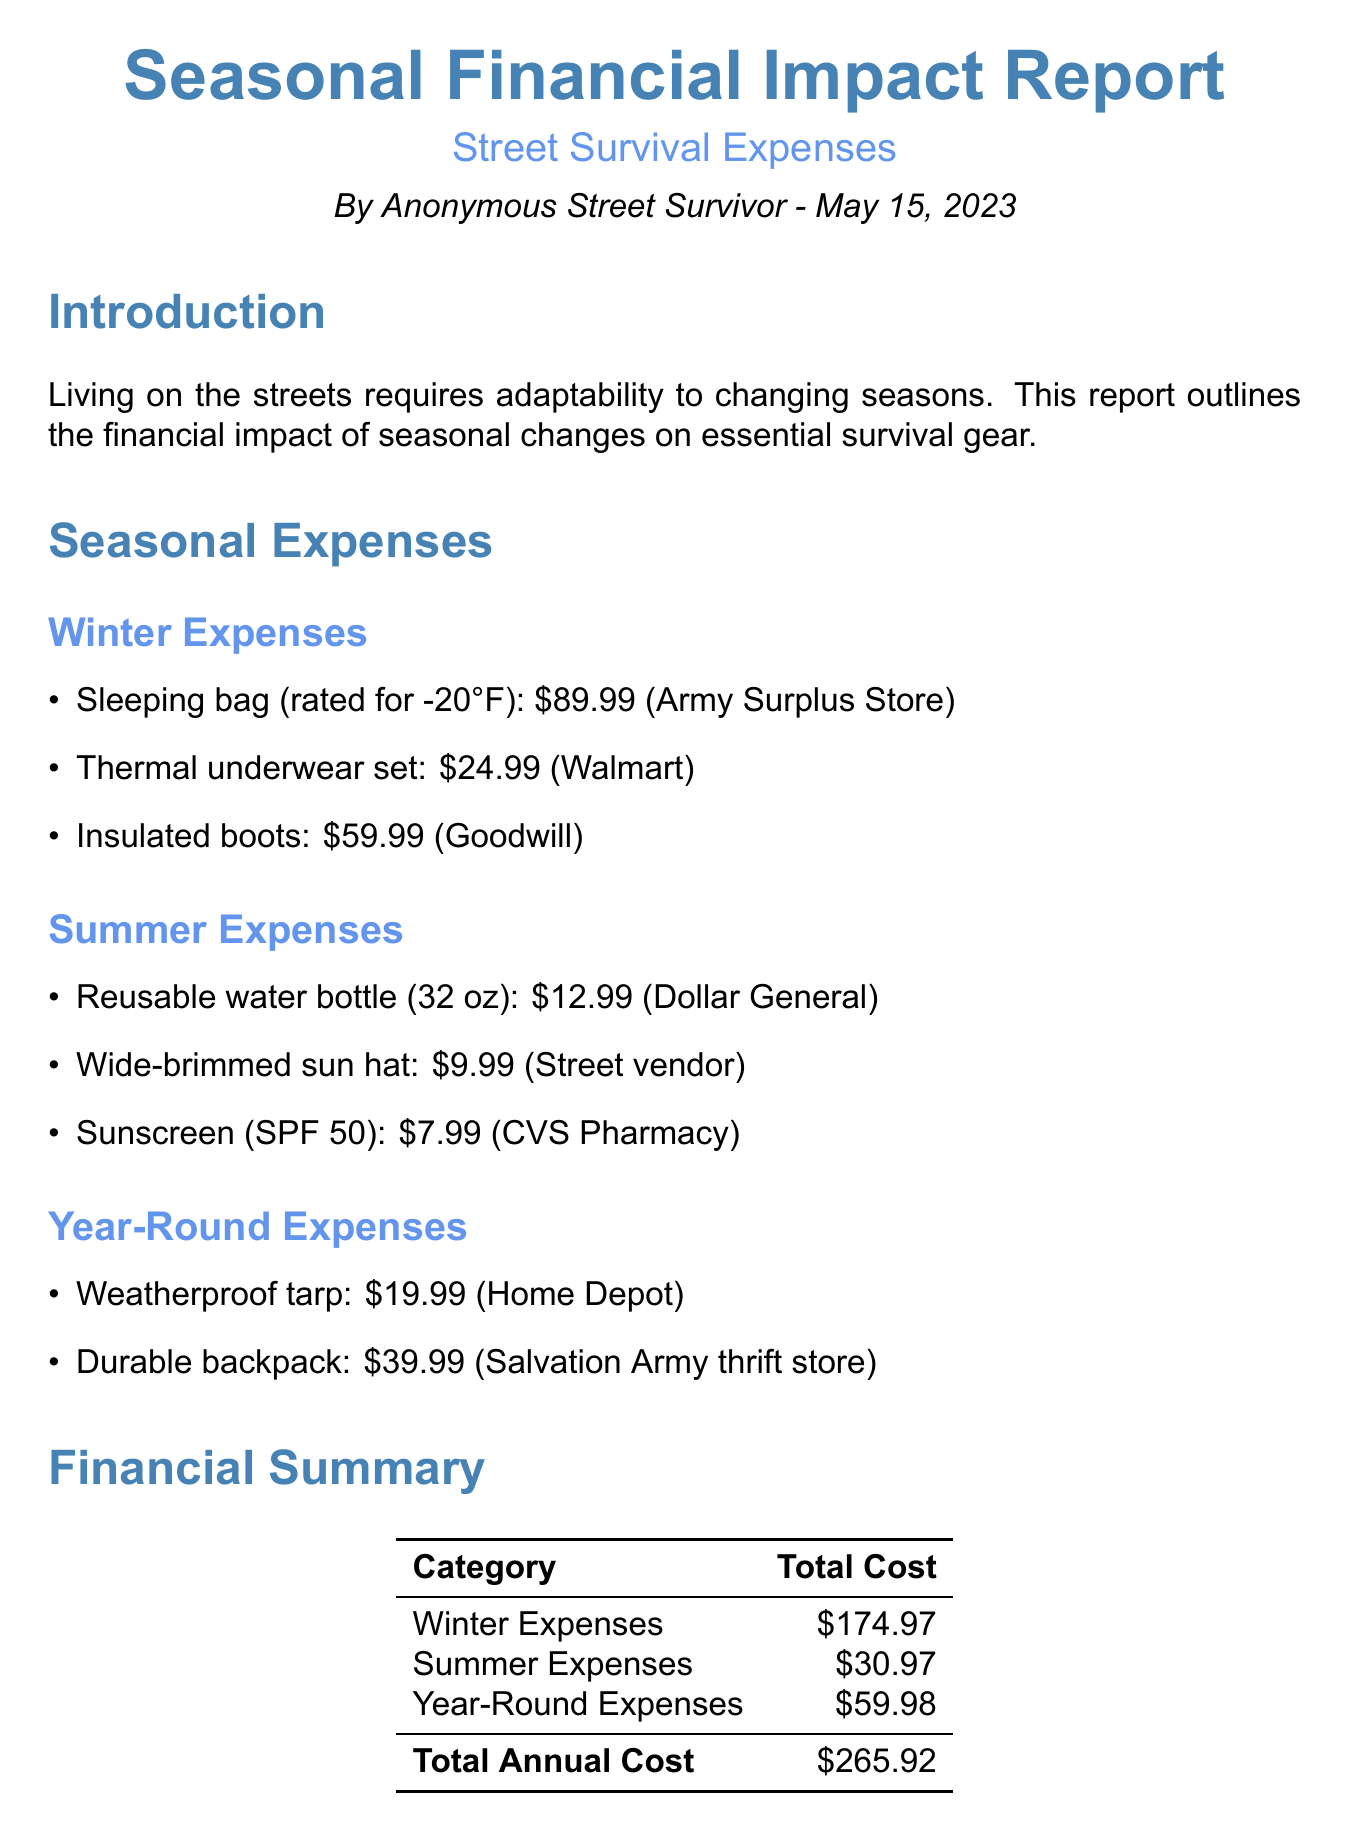What is the date of the report? The report is dated May 15, 2023.
Answer: May 15, 2023 Who authored the report? The report is authored by an anonymous entity identified as "Anonymous Street Survivor."
Answer: Anonymous Street Survivor What is the total annual cost reported? The total annual cost is found in the financial summary section of the report.
Answer: $265.92 How much does a weatherproof tarp cost? The cost of a weatherproof tarp is listed in the year-round expenses section.
Answer: $19.99 What item is mentioned for summer hydration? The document specifies a reusable water bottle as a summer hydration item.
Answer: Reusable water bottle What is the cost of insulated boots? The cost is listed under the winter expenses section of the report.
Answer: $59.99 What is one cost-saving tip mentioned? The document lists multiple tips; one of them pertains to clothing donations from shelters.
Answer: Utilize free clothing donations from local shelters What is the total cost of winter expenses? The total cost of winter expenses is displayed in the financial summary table.
Answer: $174.97 What type of report is this? The report outlines financial impacts related to essential survival gear influenced by seasonal changes.
Answer: Financial impact report 